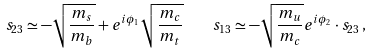Convert formula to latex. <formula><loc_0><loc_0><loc_500><loc_500>s _ { 2 3 } \simeq - \sqrt { { \frac { m _ { s } } { m _ { b } } } } + e ^ { i \phi _ { 1 } } \sqrt { { \frac { m _ { c } } { m _ { t } } } } \quad s _ { 1 3 } \simeq - \sqrt { { \frac { m _ { u } } { m _ { c } } } } e ^ { i \phi _ { 2 } } \cdot s _ { 2 3 } \, ,</formula> 